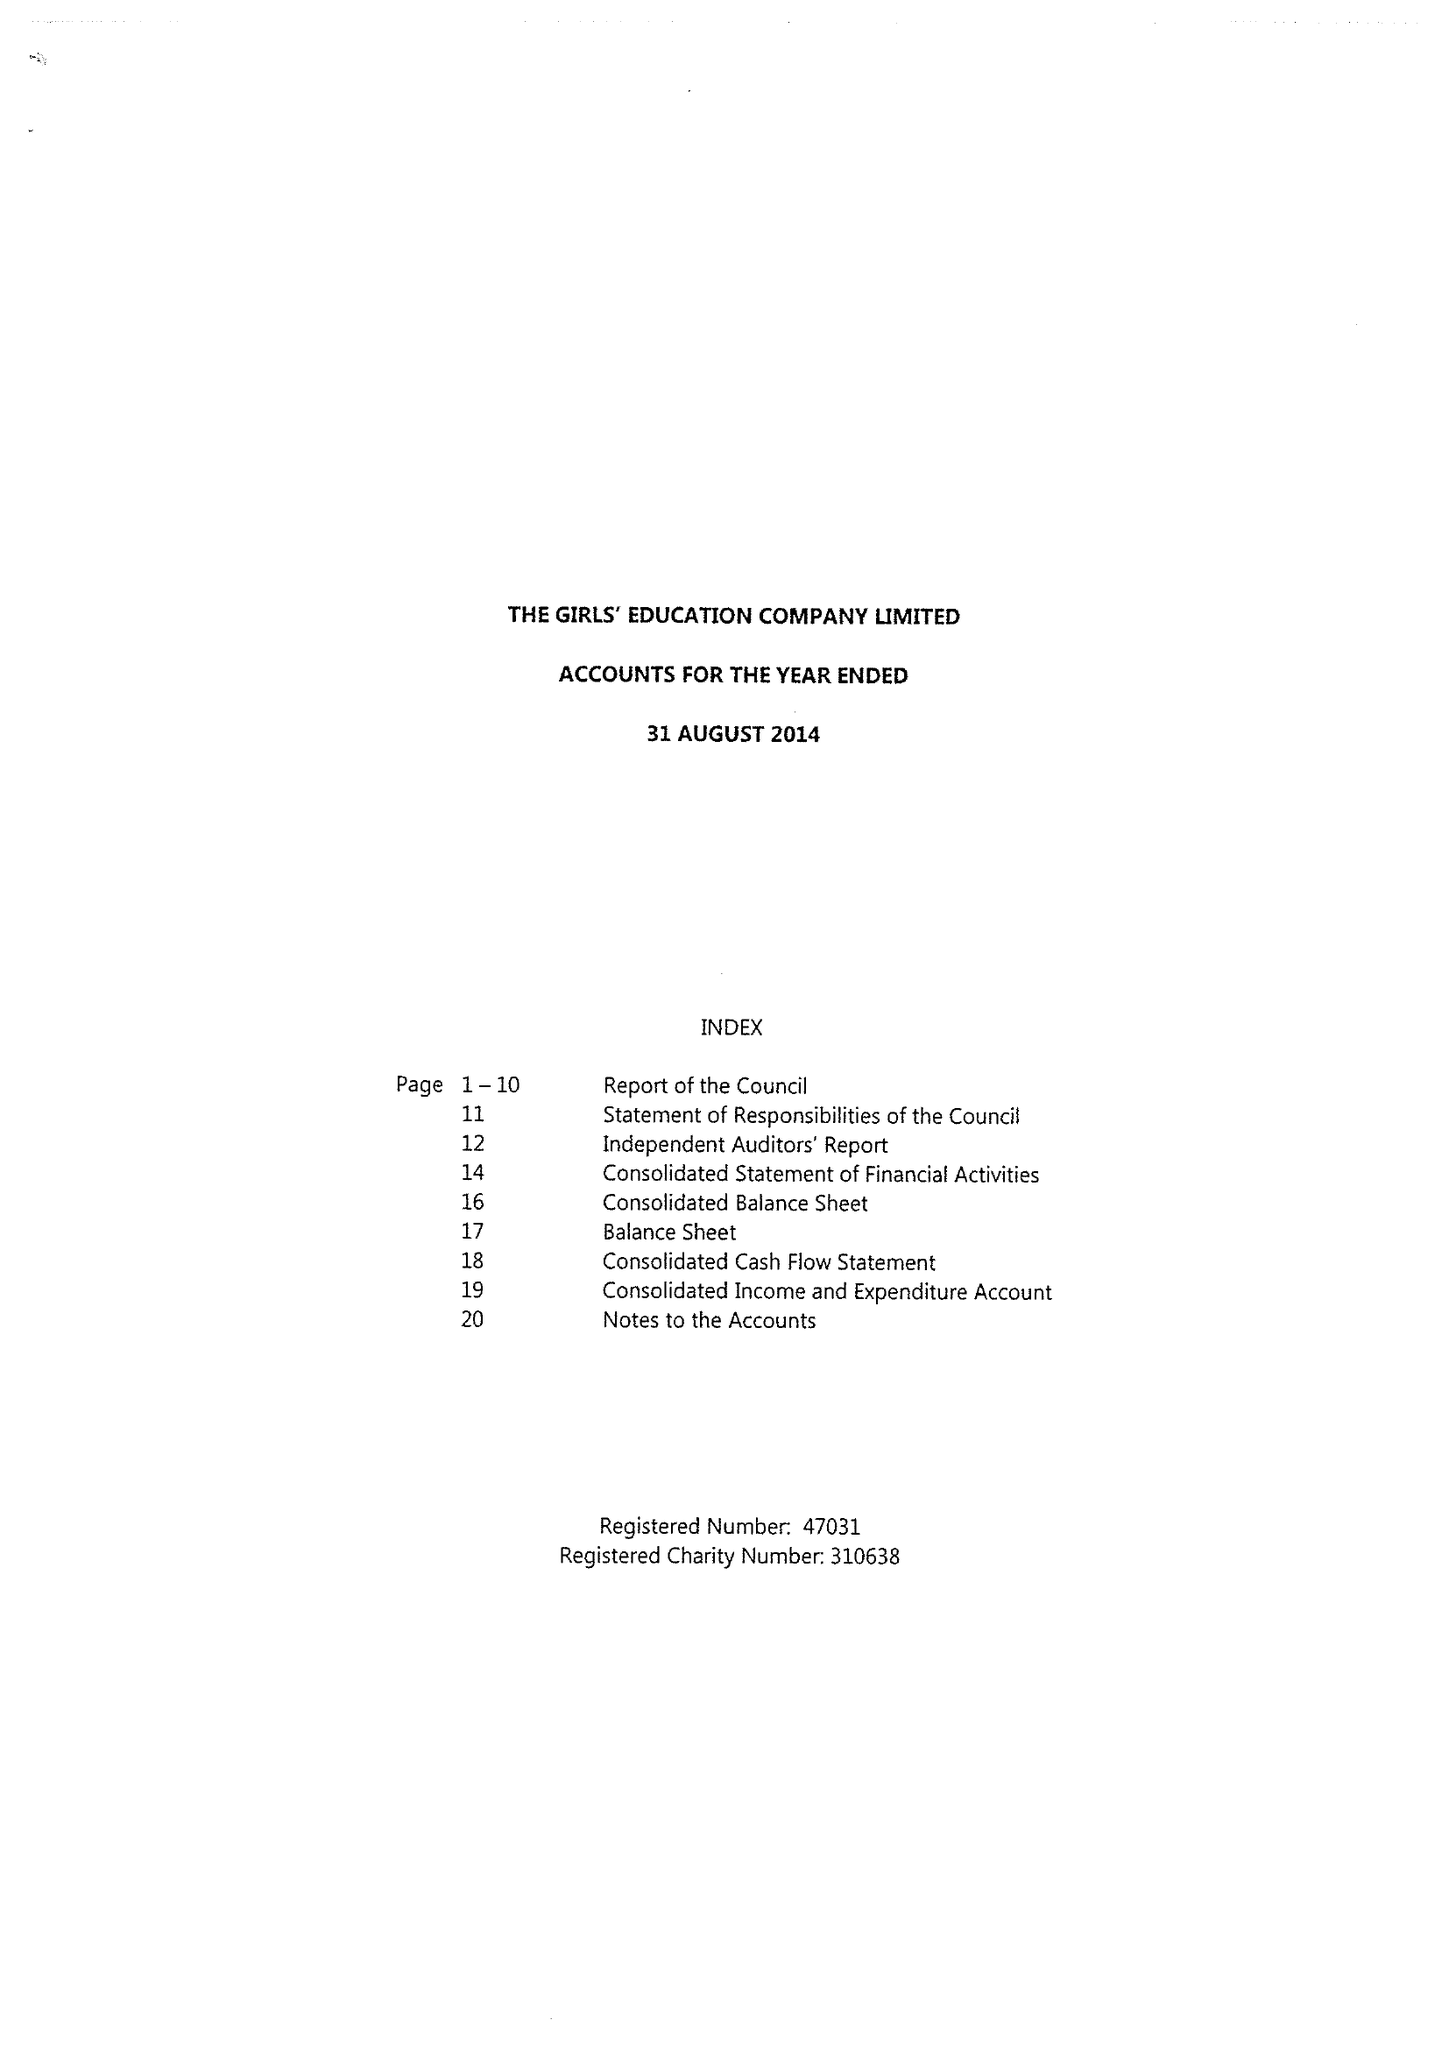What is the value for the address__post_town?
Answer the question using a single word or phrase. HIGH WYCOMBE 